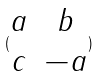Convert formula to latex. <formula><loc_0><loc_0><loc_500><loc_500>( \begin{matrix} a & b \\ c & - a \end{matrix} )</formula> 